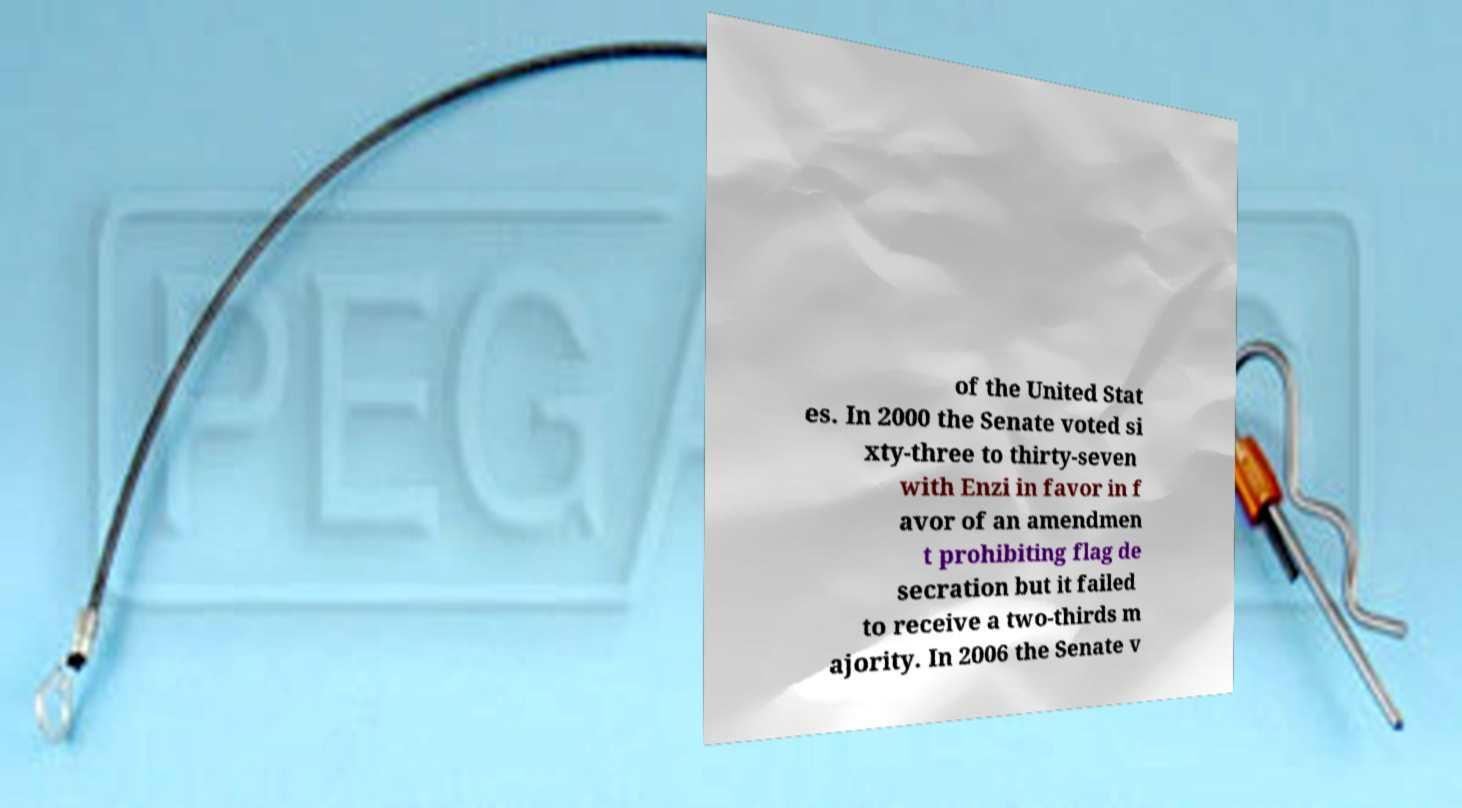Please read and relay the text visible in this image. What does it say? of the United Stat es. In 2000 the Senate voted si xty-three to thirty-seven with Enzi in favor in f avor of an amendmen t prohibiting flag de secration but it failed to receive a two-thirds m ajority. In 2006 the Senate v 